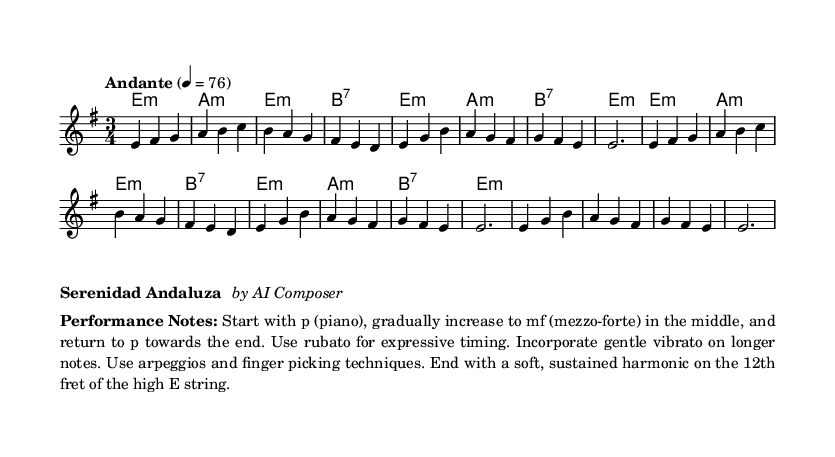What is the key signature of this music? The key signature indicated in the music is E minor, which has one sharp, F sharp. It is determined by looking at the 'key' directive in the melody section.
Answer: E minor What is the time signature of this music? The time signature is 3/4, which can be identified from the symbols appearing at the beginning of the melody section. This indicates three beats per measure, with a quarter note receiving one beat.
Answer: 3/4 What is the tempo marking of this music? The tempo marking is 'Andante', which is noted in the tempo indication at the beginning of the score. This term indicates a moderate walking pace for the piece.
Answer: Andante How many bars are in the A section? The A section consists of 8 bars, as seen from the structure of the melody in the score where the A section is defined and ends before the B section starts.
Answer: 8 What types of chords are primarily used in the harmonies section? The harmonies section indicates minor and seventh chords, as seen throughout the chord names listed. Specifically, E minor, A minor, and B seventh appear in the chord progression.
Answer: Minor and seventh What is the performance dynamic advised for the piece? The performance notes suggest starting softly (p), building to a mezzo-forte (mf) in the middle, and returning to soft (p) towards the end. This is indicated in the performance notes that describe the dynamic changes throughout the piece.
Answer: p to mf and back to p Which specific playing techniques are recommended in the performance notes? The performance notes recommend using techniques like rubato for expressive timing, gentle vibrato on longer notes, and finger picking techniques throughout the piece. This is specifically mentioned to enhance the expressiveness of the performance.
Answer: Rubato, vibrato, finger picking 